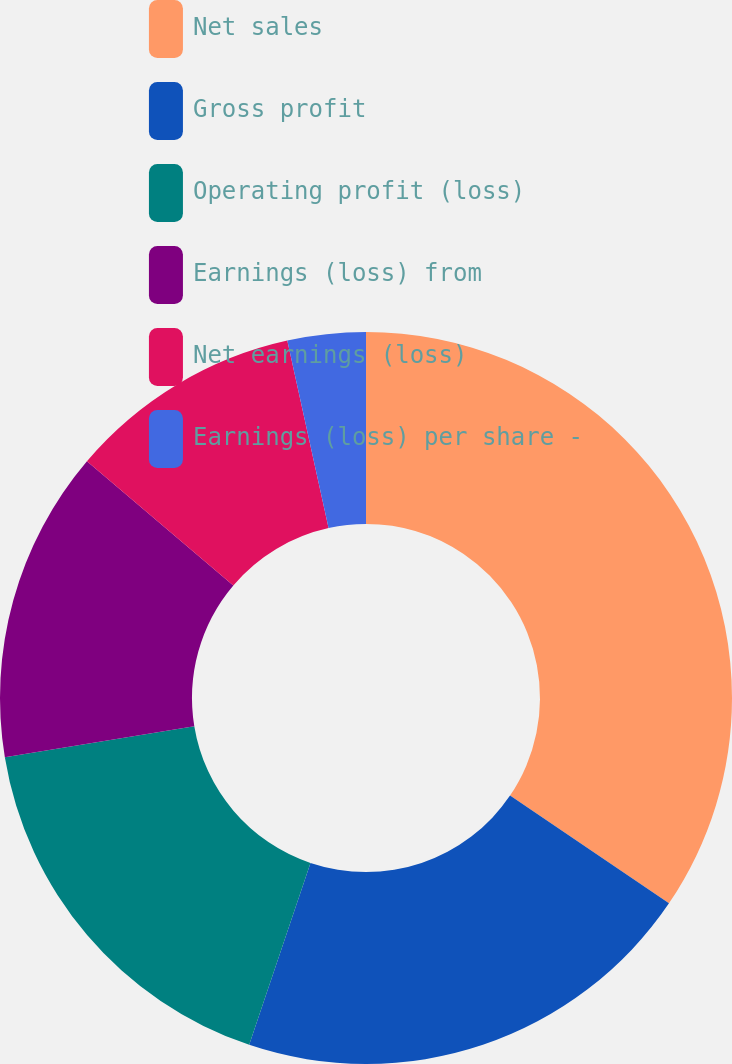<chart> <loc_0><loc_0><loc_500><loc_500><pie_chart><fcel>Net sales<fcel>Gross profit<fcel>Operating profit (loss)<fcel>Earnings (loss) from<fcel>Net earnings (loss)<fcel>Earnings (loss) per share -<nl><fcel>34.48%<fcel>20.69%<fcel>17.24%<fcel>13.79%<fcel>10.35%<fcel>3.45%<nl></chart> 